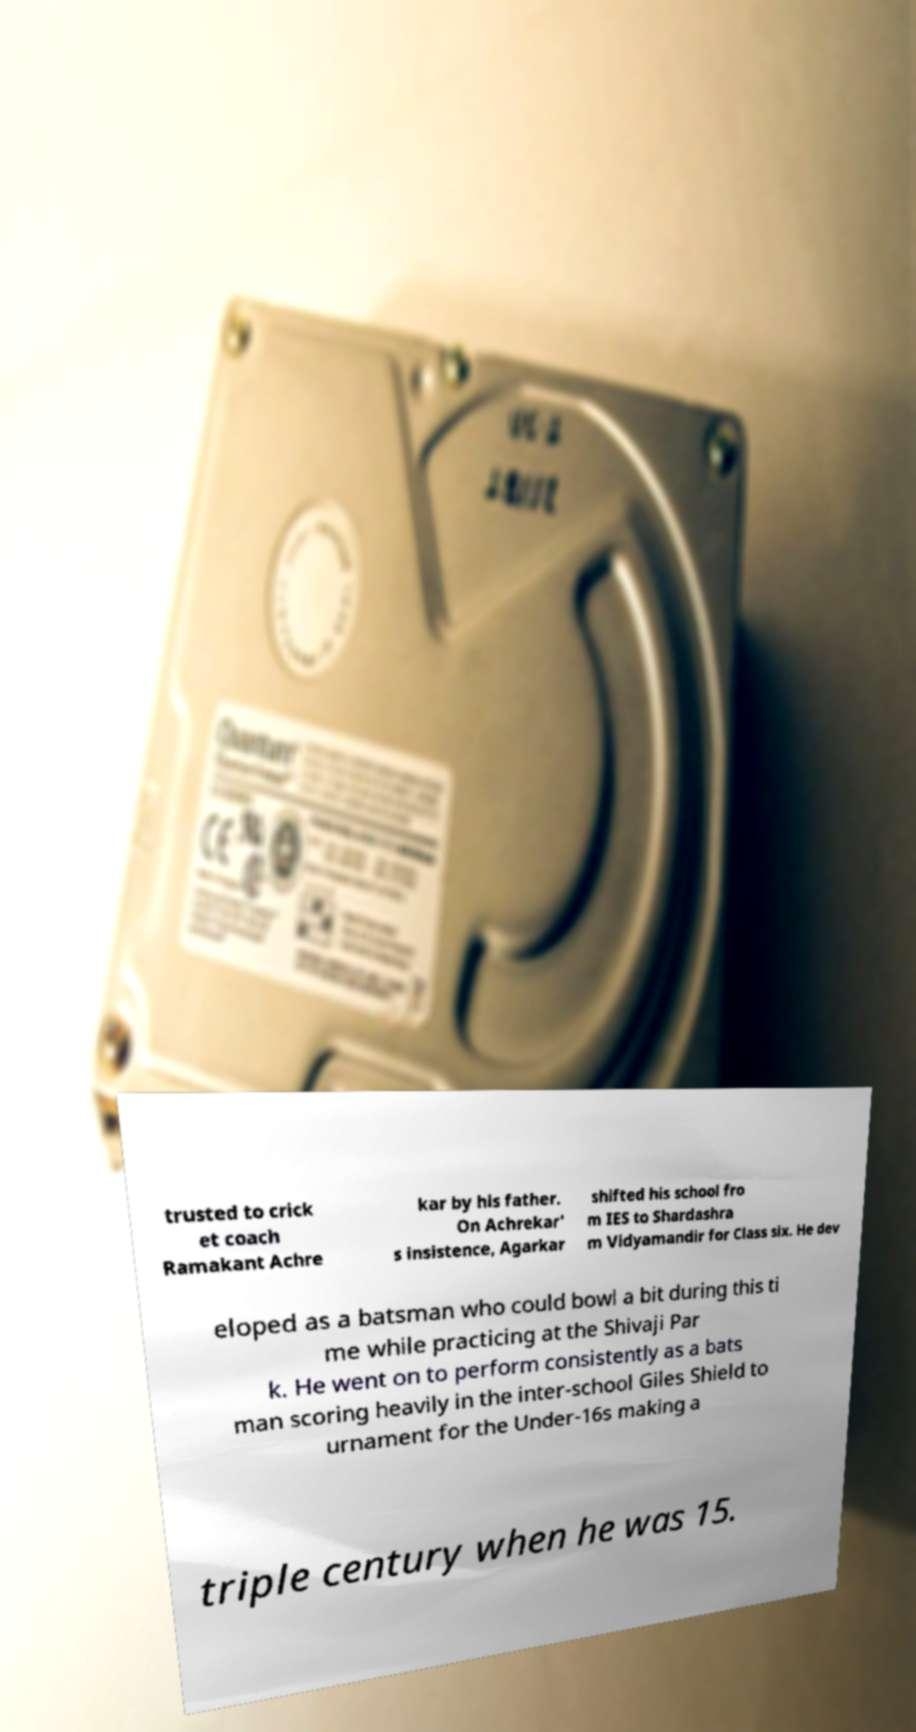I need the written content from this picture converted into text. Can you do that? trusted to crick et coach Ramakant Achre kar by his father. On Achrekar' s insistence, Agarkar shifted his school fro m IES to Shardashra m Vidyamandir for Class six. He dev eloped as a batsman who could bowl a bit during this ti me while practicing at the Shivaji Par k. He went on to perform consistently as a bats man scoring heavily in the inter-school Giles Shield to urnament for the Under-16s making a triple century when he was 15. 